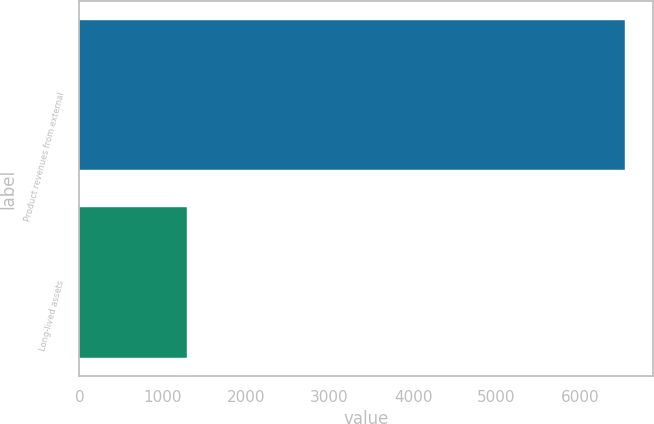<chart> <loc_0><loc_0><loc_500><loc_500><bar_chart><fcel>Product revenues from external<fcel>Long-lived assets<nl><fcel>6545.8<fcel>1296.5<nl></chart> 